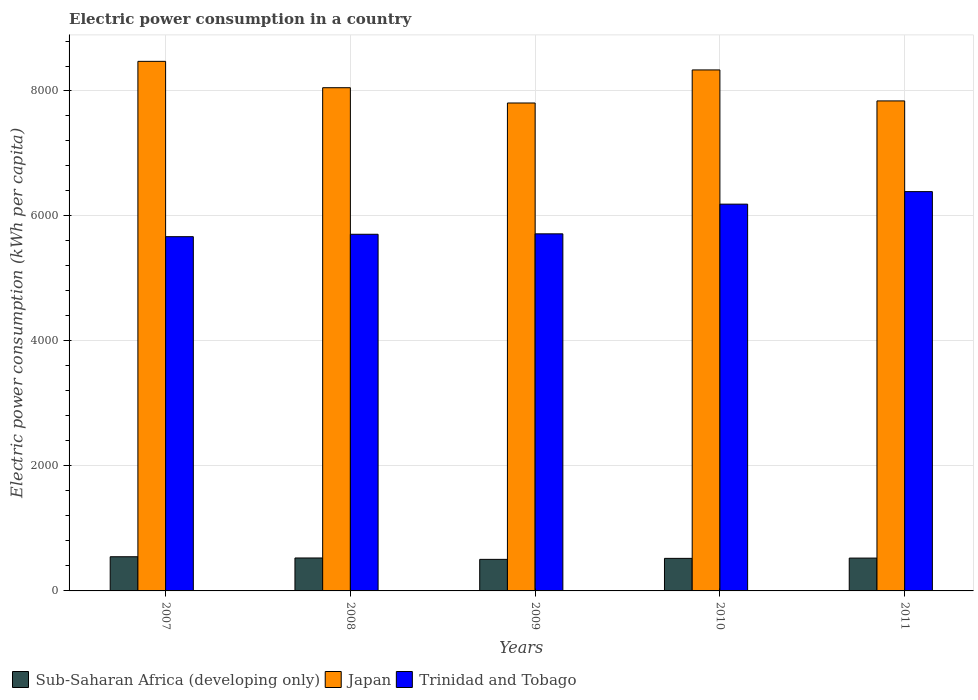How many groups of bars are there?
Your response must be concise. 5. How many bars are there on the 2nd tick from the right?
Keep it short and to the point. 3. What is the label of the 4th group of bars from the left?
Keep it short and to the point. 2010. In how many cases, is the number of bars for a given year not equal to the number of legend labels?
Provide a succinct answer. 0. What is the electric power consumption in in Sub-Saharan Africa (developing only) in 2010?
Offer a very short reply. 520.92. Across all years, what is the maximum electric power consumption in in Japan?
Provide a succinct answer. 8474.38. Across all years, what is the minimum electric power consumption in in Japan?
Keep it short and to the point. 7808.07. In which year was the electric power consumption in in Trinidad and Tobago maximum?
Offer a terse response. 2011. What is the total electric power consumption in in Trinidad and Tobago in the graph?
Provide a short and direct response. 2.97e+04. What is the difference between the electric power consumption in in Sub-Saharan Africa (developing only) in 2007 and that in 2009?
Provide a succinct answer. 42.01. What is the difference between the electric power consumption in in Trinidad and Tobago in 2008 and the electric power consumption in in Japan in 2007?
Ensure brevity in your answer.  -2767.25. What is the average electric power consumption in in Trinidad and Tobago per year?
Your answer should be compact. 5933.85. In the year 2011, what is the difference between the electric power consumption in in Japan and electric power consumption in in Trinidad and Tobago?
Make the answer very short. 1451.53. In how many years, is the electric power consumption in in Trinidad and Tobago greater than 8400 kWh per capita?
Offer a terse response. 0. What is the ratio of the electric power consumption in in Japan in 2007 to that in 2008?
Offer a very short reply. 1.05. What is the difference between the highest and the second highest electric power consumption in in Trinidad and Tobago?
Keep it short and to the point. 200.45. What is the difference between the highest and the lowest electric power consumption in in Japan?
Provide a succinct answer. 666.31. What does the 1st bar from the left in 2008 represents?
Offer a terse response. Sub-Saharan Africa (developing only). What does the 1st bar from the right in 2010 represents?
Your response must be concise. Trinidad and Tobago. Is it the case that in every year, the sum of the electric power consumption in in Sub-Saharan Africa (developing only) and electric power consumption in in Japan is greater than the electric power consumption in in Trinidad and Tobago?
Provide a succinct answer. Yes. What is the difference between two consecutive major ticks on the Y-axis?
Offer a terse response. 2000. Are the values on the major ticks of Y-axis written in scientific E-notation?
Provide a short and direct response. No. Where does the legend appear in the graph?
Keep it short and to the point. Bottom left. How are the legend labels stacked?
Make the answer very short. Horizontal. What is the title of the graph?
Your answer should be compact. Electric power consumption in a country. Does "Tonga" appear as one of the legend labels in the graph?
Give a very brief answer. No. What is the label or title of the Y-axis?
Your answer should be very brief. Electric power consumption (kWh per capita). What is the Electric power consumption (kWh per capita) in Sub-Saharan Africa (developing only) in 2007?
Your response must be concise. 546.91. What is the Electric power consumption (kWh per capita) in Japan in 2007?
Ensure brevity in your answer.  8474.38. What is the Electric power consumption (kWh per capita) of Trinidad and Tobago in 2007?
Your response must be concise. 5668.85. What is the Electric power consumption (kWh per capita) in Sub-Saharan Africa (developing only) in 2008?
Your response must be concise. 527.09. What is the Electric power consumption (kWh per capita) of Japan in 2008?
Provide a succinct answer. 8052.58. What is the Electric power consumption (kWh per capita) in Trinidad and Tobago in 2008?
Keep it short and to the point. 5707.13. What is the Electric power consumption (kWh per capita) of Sub-Saharan Africa (developing only) in 2009?
Provide a short and direct response. 504.91. What is the Electric power consumption (kWh per capita) of Japan in 2009?
Make the answer very short. 7808.07. What is the Electric power consumption (kWh per capita) of Trinidad and Tobago in 2009?
Keep it short and to the point. 5714.18. What is the Electric power consumption (kWh per capita) in Sub-Saharan Africa (developing only) in 2010?
Your answer should be very brief. 520.92. What is the Electric power consumption (kWh per capita) in Japan in 2010?
Keep it short and to the point. 8337.13. What is the Electric power consumption (kWh per capita) of Trinidad and Tobago in 2010?
Make the answer very short. 6189.32. What is the Electric power consumption (kWh per capita) in Sub-Saharan Africa (developing only) in 2011?
Ensure brevity in your answer.  525.35. What is the Electric power consumption (kWh per capita) of Japan in 2011?
Offer a terse response. 7841.3. What is the Electric power consumption (kWh per capita) in Trinidad and Tobago in 2011?
Provide a succinct answer. 6389.77. Across all years, what is the maximum Electric power consumption (kWh per capita) in Sub-Saharan Africa (developing only)?
Your response must be concise. 546.91. Across all years, what is the maximum Electric power consumption (kWh per capita) in Japan?
Make the answer very short. 8474.38. Across all years, what is the maximum Electric power consumption (kWh per capita) of Trinidad and Tobago?
Make the answer very short. 6389.77. Across all years, what is the minimum Electric power consumption (kWh per capita) in Sub-Saharan Africa (developing only)?
Your answer should be very brief. 504.91. Across all years, what is the minimum Electric power consumption (kWh per capita) of Japan?
Provide a short and direct response. 7808.07. Across all years, what is the minimum Electric power consumption (kWh per capita) in Trinidad and Tobago?
Provide a succinct answer. 5668.85. What is the total Electric power consumption (kWh per capita) of Sub-Saharan Africa (developing only) in the graph?
Your response must be concise. 2625.18. What is the total Electric power consumption (kWh per capita) in Japan in the graph?
Your response must be concise. 4.05e+04. What is the total Electric power consumption (kWh per capita) in Trinidad and Tobago in the graph?
Keep it short and to the point. 2.97e+04. What is the difference between the Electric power consumption (kWh per capita) in Sub-Saharan Africa (developing only) in 2007 and that in 2008?
Provide a succinct answer. 19.83. What is the difference between the Electric power consumption (kWh per capita) of Japan in 2007 and that in 2008?
Provide a succinct answer. 421.8. What is the difference between the Electric power consumption (kWh per capita) of Trinidad and Tobago in 2007 and that in 2008?
Provide a short and direct response. -38.28. What is the difference between the Electric power consumption (kWh per capita) in Sub-Saharan Africa (developing only) in 2007 and that in 2009?
Make the answer very short. 42.01. What is the difference between the Electric power consumption (kWh per capita) of Japan in 2007 and that in 2009?
Give a very brief answer. 666.31. What is the difference between the Electric power consumption (kWh per capita) in Trinidad and Tobago in 2007 and that in 2009?
Make the answer very short. -45.33. What is the difference between the Electric power consumption (kWh per capita) in Sub-Saharan Africa (developing only) in 2007 and that in 2010?
Provide a succinct answer. 26. What is the difference between the Electric power consumption (kWh per capita) in Japan in 2007 and that in 2010?
Your answer should be very brief. 137.25. What is the difference between the Electric power consumption (kWh per capita) of Trinidad and Tobago in 2007 and that in 2010?
Make the answer very short. -520.47. What is the difference between the Electric power consumption (kWh per capita) of Sub-Saharan Africa (developing only) in 2007 and that in 2011?
Provide a succinct answer. 21.56. What is the difference between the Electric power consumption (kWh per capita) in Japan in 2007 and that in 2011?
Ensure brevity in your answer.  633.08. What is the difference between the Electric power consumption (kWh per capita) in Trinidad and Tobago in 2007 and that in 2011?
Make the answer very short. -720.92. What is the difference between the Electric power consumption (kWh per capita) in Sub-Saharan Africa (developing only) in 2008 and that in 2009?
Keep it short and to the point. 22.18. What is the difference between the Electric power consumption (kWh per capita) of Japan in 2008 and that in 2009?
Give a very brief answer. 244.51. What is the difference between the Electric power consumption (kWh per capita) of Trinidad and Tobago in 2008 and that in 2009?
Your response must be concise. -7.05. What is the difference between the Electric power consumption (kWh per capita) of Sub-Saharan Africa (developing only) in 2008 and that in 2010?
Provide a succinct answer. 6.17. What is the difference between the Electric power consumption (kWh per capita) in Japan in 2008 and that in 2010?
Offer a terse response. -284.55. What is the difference between the Electric power consumption (kWh per capita) in Trinidad and Tobago in 2008 and that in 2010?
Offer a very short reply. -482.19. What is the difference between the Electric power consumption (kWh per capita) of Sub-Saharan Africa (developing only) in 2008 and that in 2011?
Your response must be concise. 1.73. What is the difference between the Electric power consumption (kWh per capita) in Japan in 2008 and that in 2011?
Provide a short and direct response. 211.27. What is the difference between the Electric power consumption (kWh per capita) in Trinidad and Tobago in 2008 and that in 2011?
Give a very brief answer. -682.64. What is the difference between the Electric power consumption (kWh per capita) of Sub-Saharan Africa (developing only) in 2009 and that in 2010?
Offer a terse response. -16.01. What is the difference between the Electric power consumption (kWh per capita) of Japan in 2009 and that in 2010?
Your answer should be very brief. -529.06. What is the difference between the Electric power consumption (kWh per capita) of Trinidad and Tobago in 2009 and that in 2010?
Give a very brief answer. -475.13. What is the difference between the Electric power consumption (kWh per capita) of Sub-Saharan Africa (developing only) in 2009 and that in 2011?
Provide a short and direct response. -20.45. What is the difference between the Electric power consumption (kWh per capita) in Japan in 2009 and that in 2011?
Your response must be concise. -33.23. What is the difference between the Electric power consumption (kWh per capita) in Trinidad and Tobago in 2009 and that in 2011?
Your response must be concise. -675.59. What is the difference between the Electric power consumption (kWh per capita) of Sub-Saharan Africa (developing only) in 2010 and that in 2011?
Give a very brief answer. -4.43. What is the difference between the Electric power consumption (kWh per capita) of Japan in 2010 and that in 2011?
Your response must be concise. 495.83. What is the difference between the Electric power consumption (kWh per capita) of Trinidad and Tobago in 2010 and that in 2011?
Keep it short and to the point. -200.45. What is the difference between the Electric power consumption (kWh per capita) in Sub-Saharan Africa (developing only) in 2007 and the Electric power consumption (kWh per capita) in Japan in 2008?
Your answer should be very brief. -7505.66. What is the difference between the Electric power consumption (kWh per capita) in Sub-Saharan Africa (developing only) in 2007 and the Electric power consumption (kWh per capita) in Trinidad and Tobago in 2008?
Ensure brevity in your answer.  -5160.22. What is the difference between the Electric power consumption (kWh per capita) of Japan in 2007 and the Electric power consumption (kWh per capita) of Trinidad and Tobago in 2008?
Keep it short and to the point. 2767.25. What is the difference between the Electric power consumption (kWh per capita) in Sub-Saharan Africa (developing only) in 2007 and the Electric power consumption (kWh per capita) in Japan in 2009?
Offer a very short reply. -7261.16. What is the difference between the Electric power consumption (kWh per capita) in Sub-Saharan Africa (developing only) in 2007 and the Electric power consumption (kWh per capita) in Trinidad and Tobago in 2009?
Offer a terse response. -5167.27. What is the difference between the Electric power consumption (kWh per capita) of Japan in 2007 and the Electric power consumption (kWh per capita) of Trinidad and Tobago in 2009?
Provide a short and direct response. 2760.2. What is the difference between the Electric power consumption (kWh per capita) of Sub-Saharan Africa (developing only) in 2007 and the Electric power consumption (kWh per capita) of Japan in 2010?
Your answer should be very brief. -7790.21. What is the difference between the Electric power consumption (kWh per capita) in Sub-Saharan Africa (developing only) in 2007 and the Electric power consumption (kWh per capita) in Trinidad and Tobago in 2010?
Provide a succinct answer. -5642.4. What is the difference between the Electric power consumption (kWh per capita) in Japan in 2007 and the Electric power consumption (kWh per capita) in Trinidad and Tobago in 2010?
Offer a very short reply. 2285.06. What is the difference between the Electric power consumption (kWh per capita) of Sub-Saharan Africa (developing only) in 2007 and the Electric power consumption (kWh per capita) of Japan in 2011?
Provide a succinct answer. -7294.39. What is the difference between the Electric power consumption (kWh per capita) of Sub-Saharan Africa (developing only) in 2007 and the Electric power consumption (kWh per capita) of Trinidad and Tobago in 2011?
Offer a very short reply. -5842.85. What is the difference between the Electric power consumption (kWh per capita) in Japan in 2007 and the Electric power consumption (kWh per capita) in Trinidad and Tobago in 2011?
Provide a short and direct response. 2084.61. What is the difference between the Electric power consumption (kWh per capita) in Sub-Saharan Africa (developing only) in 2008 and the Electric power consumption (kWh per capita) in Japan in 2009?
Ensure brevity in your answer.  -7280.99. What is the difference between the Electric power consumption (kWh per capita) of Sub-Saharan Africa (developing only) in 2008 and the Electric power consumption (kWh per capita) of Trinidad and Tobago in 2009?
Make the answer very short. -5187.1. What is the difference between the Electric power consumption (kWh per capita) in Japan in 2008 and the Electric power consumption (kWh per capita) in Trinidad and Tobago in 2009?
Offer a very short reply. 2338.39. What is the difference between the Electric power consumption (kWh per capita) of Sub-Saharan Africa (developing only) in 2008 and the Electric power consumption (kWh per capita) of Japan in 2010?
Your response must be concise. -7810.04. What is the difference between the Electric power consumption (kWh per capita) of Sub-Saharan Africa (developing only) in 2008 and the Electric power consumption (kWh per capita) of Trinidad and Tobago in 2010?
Ensure brevity in your answer.  -5662.23. What is the difference between the Electric power consumption (kWh per capita) in Japan in 2008 and the Electric power consumption (kWh per capita) in Trinidad and Tobago in 2010?
Offer a terse response. 1863.26. What is the difference between the Electric power consumption (kWh per capita) of Sub-Saharan Africa (developing only) in 2008 and the Electric power consumption (kWh per capita) of Japan in 2011?
Ensure brevity in your answer.  -7314.22. What is the difference between the Electric power consumption (kWh per capita) in Sub-Saharan Africa (developing only) in 2008 and the Electric power consumption (kWh per capita) in Trinidad and Tobago in 2011?
Make the answer very short. -5862.68. What is the difference between the Electric power consumption (kWh per capita) in Japan in 2008 and the Electric power consumption (kWh per capita) in Trinidad and Tobago in 2011?
Provide a short and direct response. 1662.81. What is the difference between the Electric power consumption (kWh per capita) of Sub-Saharan Africa (developing only) in 2009 and the Electric power consumption (kWh per capita) of Japan in 2010?
Provide a succinct answer. -7832.22. What is the difference between the Electric power consumption (kWh per capita) in Sub-Saharan Africa (developing only) in 2009 and the Electric power consumption (kWh per capita) in Trinidad and Tobago in 2010?
Provide a short and direct response. -5684.41. What is the difference between the Electric power consumption (kWh per capita) of Japan in 2009 and the Electric power consumption (kWh per capita) of Trinidad and Tobago in 2010?
Provide a succinct answer. 1618.75. What is the difference between the Electric power consumption (kWh per capita) of Sub-Saharan Africa (developing only) in 2009 and the Electric power consumption (kWh per capita) of Japan in 2011?
Your answer should be compact. -7336.4. What is the difference between the Electric power consumption (kWh per capita) of Sub-Saharan Africa (developing only) in 2009 and the Electric power consumption (kWh per capita) of Trinidad and Tobago in 2011?
Offer a terse response. -5884.86. What is the difference between the Electric power consumption (kWh per capita) of Japan in 2009 and the Electric power consumption (kWh per capita) of Trinidad and Tobago in 2011?
Provide a succinct answer. 1418.3. What is the difference between the Electric power consumption (kWh per capita) of Sub-Saharan Africa (developing only) in 2010 and the Electric power consumption (kWh per capita) of Japan in 2011?
Provide a succinct answer. -7320.38. What is the difference between the Electric power consumption (kWh per capita) in Sub-Saharan Africa (developing only) in 2010 and the Electric power consumption (kWh per capita) in Trinidad and Tobago in 2011?
Make the answer very short. -5868.85. What is the difference between the Electric power consumption (kWh per capita) in Japan in 2010 and the Electric power consumption (kWh per capita) in Trinidad and Tobago in 2011?
Provide a short and direct response. 1947.36. What is the average Electric power consumption (kWh per capita) in Sub-Saharan Africa (developing only) per year?
Your response must be concise. 525.04. What is the average Electric power consumption (kWh per capita) in Japan per year?
Ensure brevity in your answer.  8102.69. What is the average Electric power consumption (kWh per capita) of Trinidad and Tobago per year?
Your answer should be very brief. 5933.85. In the year 2007, what is the difference between the Electric power consumption (kWh per capita) in Sub-Saharan Africa (developing only) and Electric power consumption (kWh per capita) in Japan?
Ensure brevity in your answer.  -7927.46. In the year 2007, what is the difference between the Electric power consumption (kWh per capita) in Sub-Saharan Africa (developing only) and Electric power consumption (kWh per capita) in Trinidad and Tobago?
Offer a terse response. -5121.94. In the year 2007, what is the difference between the Electric power consumption (kWh per capita) in Japan and Electric power consumption (kWh per capita) in Trinidad and Tobago?
Your response must be concise. 2805.53. In the year 2008, what is the difference between the Electric power consumption (kWh per capita) of Sub-Saharan Africa (developing only) and Electric power consumption (kWh per capita) of Japan?
Offer a very short reply. -7525.49. In the year 2008, what is the difference between the Electric power consumption (kWh per capita) of Sub-Saharan Africa (developing only) and Electric power consumption (kWh per capita) of Trinidad and Tobago?
Offer a very short reply. -5180.05. In the year 2008, what is the difference between the Electric power consumption (kWh per capita) in Japan and Electric power consumption (kWh per capita) in Trinidad and Tobago?
Your answer should be compact. 2345.44. In the year 2009, what is the difference between the Electric power consumption (kWh per capita) in Sub-Saharan Africa (developing only) and Electric power consumption (kWh per capita) in Japan?
Offer a very short reply. -7303.16. In the year 2009, what is the difference between the Electric power consumption (kWh per capita) of Sub-Saharan Africa (developing only) and Electric power consumption (kWh per capita) of Trinidad and Tobago?
Make the answer very short. -5209.28. In the year 2009, what is the difference between the Electric power consumption (kWh per capita) of Japan and Electric power consumption (kWh per capita) of Trinidad and Tobago?
Make the answer very short. 2093.89. In the year 2010, what is the difference between the Electric power consumption (kWh per capita) in Sub-Saharan Africa (developing only) and Electric power consumption (kWh per capita) in Japan?
Keep it short and to the point. -7816.21. In the year 2010, what is the difference between the Electric power consumption (kWh per capita) of Sub-Saharan Africa (developing only) and Electric power consumption (kWh per capita) of Trinidad and Tobago?
Your answer should be compact. -5668.4. In the year 2010, what is the difference between the Electric power consumption (kWh per capita) of Japan and Electric power consumption (kWh per capita) of Trinidad and Tobago?
Offer a terse response. 2147.81. In the year 2011, what is the difference between the Electric power consumption (kWh per capita) in Sub-Saharan Africa (developing only) and Electric power consumption (kWh per capita) in Japan?
Keep it short and to the point. -7315.95. In the year 2011, what is the difference between the Electric power consumption (kWh per capita) of Sub-Saharan Africa (developing only) and Electric power consumption (kWh per capita) of Trinidad and Tobago?
Keep it short and to the point. -5864.41. In the year 2011, what is the difference between the Electric power consumption (kWh per capita) in Japan and Electric power consumption (kWh per capita) in Trinidad and Tobago?
Make the answer very short. 1451.53. What is the ratio of the Electric power consumption (kWh per capita) in Sub-Saharan Africa (developing only) in 2007 to that in 2008?
Make the answer very short. 1.04. What is the ratio of the Electric power consumption (kWh per capita) in Japan in 2007 to that in 2008?
Give a very brief answer. 1.05. What is the ratio of the Electric power consumption (kWh per capita) of Trinidad and Tobago in 2007 to that in 2008?
Your answer should be compact. 0.99. What is the ratio of the Electric power consumption (kWh per capita) of Sub-Saharan Africa (developing only) in 2007 to that in 2009?
Your response must be concise. 1.08. What is the ratio of the Electric power consumption (kWh per capita) of Japan in 2007 to that in 2009?
Your answer should be very brief. 1.09. What is the ratio of the Electric power consumption (kWh per capita) in Trinidad and Tobago in 2007 to that in 2009?
Provide a succinct answer. 0.99. What is the ratio of the Electric power consumption (kWh per capita) of Sub-Saharan Africa (developing only) in 2007 to that in 2010?
Offer a very short reply. 1.05. What is the ratio of the Electric power consumption (kWh per capita) of Japan in 2007 to that in 2010?
Ensure brevity in your answer.  1.02. What is the ratio of the Electric power consumption (kWh per capita) of Trinidad and Tobago in 2007 to that in 2010?
Offer a very short reply. 0.92. What is the ratio of the Electric power consumption (kWh per capita) in Sub-Saharan Africa (developing only) in 2007 to that in 2011?
Make the answer very short. 1.04. What is the ratio of the Electric power consumption (kWh per capita) in Japan in 2007 to that in 2011?
Ensure brevity in your answer.  1.08. What is the ratio of the Electric power consumption (kWh per capita) of Trinidad and Tobago in 2007 to that in 2011?
Give a very brief answer. 0.89. What is the ratio of the Electric power consumption (kWh per capita) in Sub-Saharan Africa (developing only) in 2008 to that in 2009?
Make the answer very short. 1.04. What is the ratio of the Electric power consumption (kWh per capita) in Japan in 2008 to that in 2009?
Provide a succinct answer. 1.03. What is the ratio of the Electric power consumption (kWh per capita) of Sub-Saharan Africa (developing only) in 2008 to that in 2010?
Provide a short and direct response. 1.01. What is the ratio of the Electric power consumption (kWh per capita) of Japan in 2008 to that in 2010?
Provide a succinct answer. 0.97. What is the ratio of the Electric power consumption (kWh per capita) in Trinidad and Tobago in 2008 to that in 2010?
Your response must be concise. 0.92. What is the ratio of the Electric power consumption (kWh per capita) of Sub-Saharan Africa (developing only) in 2008 to that in 2011?
Offer a terse response. 1. What is the ratio of the Electric power consumption (kWh per capita) of Japan in 2008 to that in 2011?
Offer a very short reply. 1.03. What is the ratio of the Electric power consumption (kWh per capita) of Trinidad and Tobago in 2008 to that in 2011?
Offer a very short reply. 0.89. What is the ratio of the Electric power consumption (kWh per capita) in Sub-Saharan Africa (developing only) in 2009 to that in 2010?
Provide a short and direct response. 0.97. What is the ratio of the Electric power consumption (kWh per capita) in Japan in 2009 to that in 2010?
Your answer should be very brief. 0.94. What is the ratio of the Electric power consumption (kWh per capita) of Trinidad and Tobago in 2009 to that in 2010?
Offer a very short reply. 0.92. What is the ratio of the Electric power consumption (kWh per capita) in Sub-Saharan Africa (developing only) in 2009 to that in 2011?
Make the answer very short. 0.96. What is the ratio of the Electric power consumption (kWh per capita) of Japan in 2009 to that in 2011?
Keep it short and to the point. 1. What is the ratio of the Electric power consumption (kWh per capita) of Trinidad and Tobago in 2009 to that in 2011?
Your answer should be compact. 0.89. What is the ratio of the Electric power consumption (kWh per capita) of Japan in 2010 to that in 2011?
Give a very brief answer. 1.06. What is the ratio of the Electric power consumption (kWh per capita) in Trinidad and Tobago in 2010 to that in 2011?
Offer a terse response. 0.97. What is the difference between the highest and the second highest Electric power consumption (kWh per capita) in Sub-Saharan Africa (developing only)?
Your answer should be very brief. 19.83. What is the difference between the highest and the second highest Electric power consumption (kWh per capita) in Japan?
Your response must be concise. 137.25. What is the difference between the highest and the second highest Electric power consumption (kWh per capita) in Trinidad and Tobago?
Give a very brief answer. 200.45. What is the difference between the highest and the lowest Electric power consumption (kWh per capita) in Sub-Saharan Africa (developing only)?
Your answer should be compact. 42.01. What is the difference between the highest and the lowest Electric power consumption (kWh per capita) of Japan?
Offer a terse response. 666.31. What is the difference between the highest and the lowest Electric power consumption (kWh per capita) in Trinidad and Tobago?
Your answer should be compact. 720.92. 